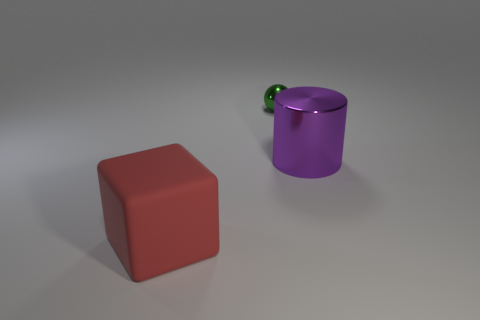Is there any other thing that has the same material as the red object?
Provide a short and direct response. No. What number of green rubber cylinders are there?
Provide a short and direct response. 0. Is the big object that is behind the red matte object made of the same material as the thing behind the big cylinder?
Give a very brief answer. Yes. What material is the big object on the right side of the green metal sphere that is on the left side of the cylinder?
Provide a succinct answer. Metal. How big is the object that is both in front of the small thing and to the left of the purple shiny cylinder?
Ensure brevity in your answer.  Large. Does the large thing behind the red block have the same material as the green ball?
Provide a succinct answer. Yes. Is there anything else that is the same size as the purple cylinder?
Ensure brevity in your answer.  Yes. Is the number of big things that are in front of the large purple metal object less than the number of green things that are to the left of the green metallic thing?
Your answer should be very brief. No. Is there any other thing that is the same shape as the large metal object?
Your response must be concise. No. What number of large metallic objects are in front of the large thing that is on the right side of the large thing that is in front of the purple cylinder?
Keep it short and to the point. 0. 